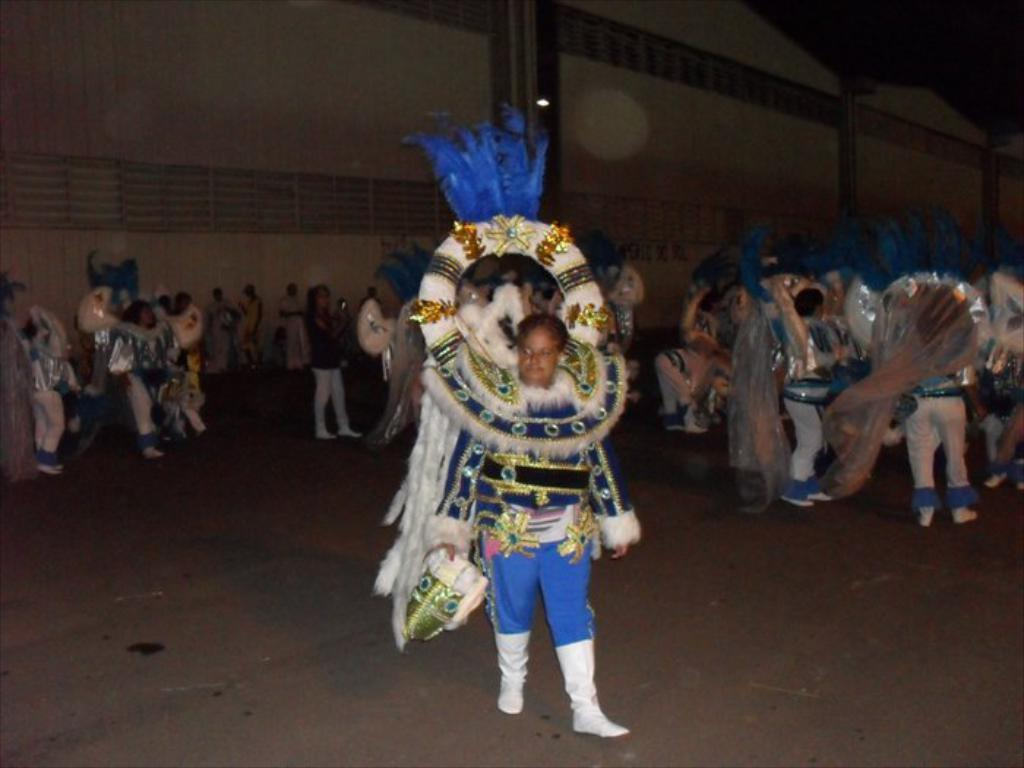Who or what can be seen in the image? There are people in the image. What are the people wearing? Most of the people are wearing costumes. What can be seen in the foreground of the image? There is a path visible in the image. What is visible in the background of the image? There is a wall in the background of the image. Are there any horses visible in the image? No, there are no horses present in the image. 